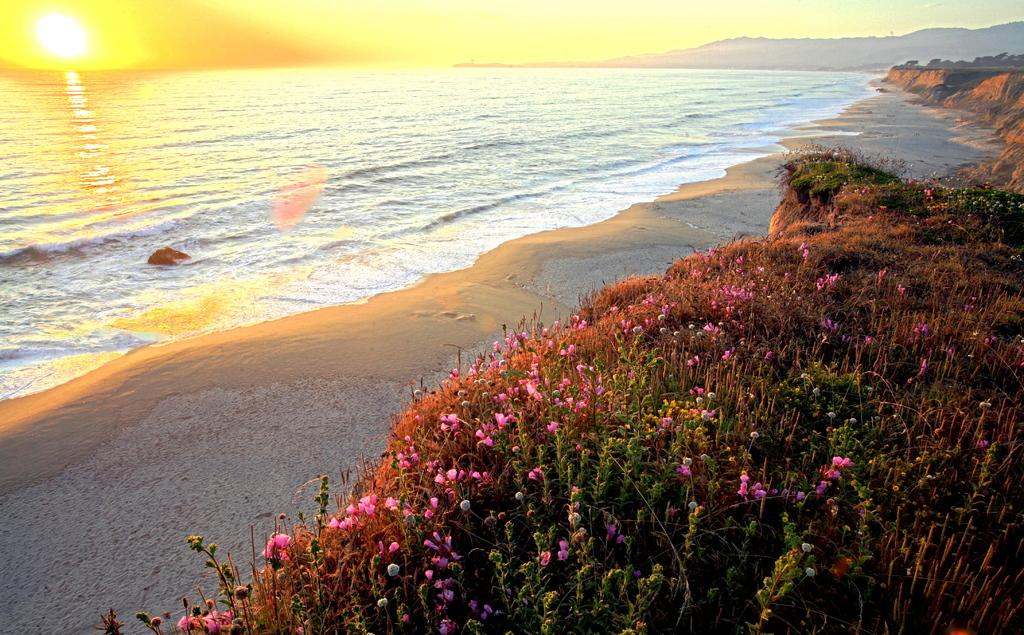What type of plants can be seen in the image? There are beautiful flowering plants in the image. What is the background of the image? There is a sea in front of the plants. How is the sea being affected by the sun in the image? Sun rays are falling on the sea. What type of cap is being worn by the flowering plants in the image? There are no caps present in the image, as the subjects are flowering plants. 